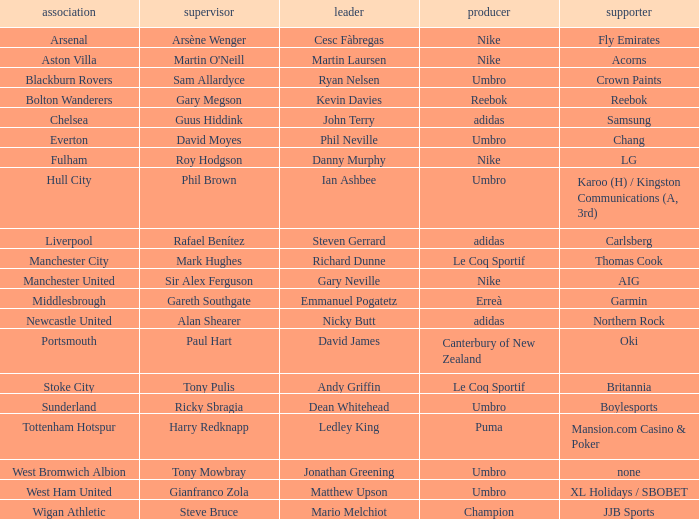In which club is Ledley King a captain? Tottenham Hotspur. 